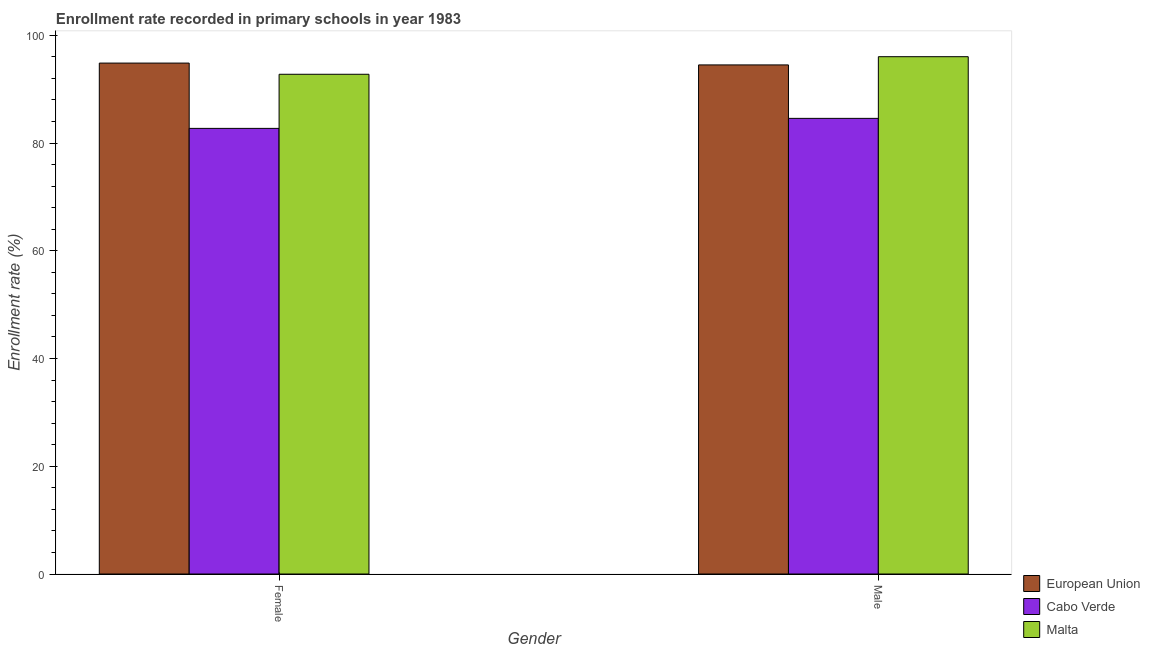How many different coloured bars are there?
Give a very brief answer. 3. How many groups of bars are there?
Your response must be concise. 2. How many bars are there on the 2nd tick from the left?
Give a very brief answer. 3. What is the enrollment rate of male students in Cabo Verde?
Provide a short and direct response. 84.59. Across all countries, what is the maximum enrollment rate of female students?
Give a very brief answer. 94.85. Across all countries, what is the minimum enrollment rate of male students?
Your response must be concise. 84.59. In which country was the enrollment rate of female students minimum?
Make the answer very short. Cabo Verde. What is the total enrollment rate of male students in the graph?
Your answer should be very brief. 275.13. What is the difference between the enrollment rate of female students in Cabo Verde and that in European Union?
Give a very brief answer. -12.12. What is the difference between the enrollment rate of female students in Cabo Verde and the enrollment rate of male students in European Union?
Provide a short and direct response. -11.78. What is the average enrollment rate of female students per country?
Offer a terse response. 90.12. What is the difference between the enrollment rate of female students and enrollment rate of male students in Cabo Verde?
Offer a very short reply. -1.86. In how many countries, is the enrollment rate of male students greater than 24 %?
Your response must be concise. 3. What is the ratio of the enrollment rate of male students in European Union to that in Cabo Verde?
Provide a succinct answer. 1.12. Is the enrollment rate of female students in Malta less than that in Cabo Verde?
Your answer should be compact. No. What does the 1st bar from the left in Female represents?
Provide a short and direct response. European Union. What does the 2nd bar from the right in Male represents?
Give a very brief answer. Cabo Verde. How many bars are there?
Your answer should be compact. 6. Are the values on the major ticks of Y-axis written in scientific E-notation?
Offer a terse response. No. Does the graph contain grids?
Your answer should be very brief. No. What is the title of the graph?
Provide a short and direct response. Enrollment rate recorded in primary schools in year 1983. What is the label or title of the X-axis?
Offer a terse response. Gender. What is the label or title of the Y-axis?
Your answer should be very brief. Enrollment rate (%). What is the Enrollment rate (%) of European Union in Female?
Provide a succinct answer. 94.85. What is the Enrollment rate (%) in Cabo Verde in Female?
Your answer should be very brief. 82.73. What is the Enrollment rate (%) in Malta in Female?
Offer a very short reply. 92.77. What is the Enrollment rate (%) in European Union in Male?
Give a very brief answer. 94.51. What is the Enrollment rate (%) in Cabo Verde in Male?
Your response must be concise. 84.59. What is the Enrollment rate (%) in Malta in Male?
Keep it short and to the point. 96.04. Across all Gender, what is the maximum Enrollment rate (%) of European Union?
Ensure brevity in your answer.  94.85. Across all Gender, what is the maximum Enrollment rate (%) in Cabo Verde?
Provide a short and direct response. 84.59. Across all Gender, what is the maximum Enrollment rate (%) in Malta?
Your response must be concise. 96.04. Across all Gender, what is the minimum Enrollment rate (%) in European Union?
Provide a short and direct response. 94.51. Across all Gender, what is the minimum Enrollment rate (%) of Cabo Verde?
Keep it short and to the point. 82.73. Across all Gender, what is the minimum Enrollment rate (%) of Malta?
Offer a terse response. 92.77. What is the total Enrollment rate (%) of European Union in the graph?
Keep it short and to the point. 189.36. What is the total Enrollment rate (%) of Cabo Verde in the graph?
Provide a succinct answer. 167.31. What is the total Enrollment rate (%) of Malta in the graph?
Make the answer very short. 188.81. What is the difference between the Enrollment rate (%) in European Union in Female and that in Male?
Provide a succinct answer. 0.34. What is the difference between the Enrollment rate (%) in Cabo Verde in Female and that in Male?
Offer a very short reply. -1.86. What is the difference between the Enrollment rate (%) in Malta in Female and that in Male?
Offer a terse response. -3.26. What is the difference between the Enrollment rate (%) in European Union in Female and the Enrollment rate (%) in Cabo Verde in Male?
Your response must be concise. 10.26. What is the difference between the Enrollment rate (%) of European Union in Female and the Enrollment rate (%) of Malta in Male?
Your response must be concise. -1.19. What is the difference between the Enrollment rate (%) in Cabo Verde in Female and the Enrollment rate (%) in Malta in Male?
Provide a short and direct response. -13.31. What is the average Enrollment rate (%) of European Union per Gender?
Make the answer very short. 94.68. What is the average Enrollment rate (%) in Cabo Verde per Gender?
Your answer should be very brief. 83.66. What is the average Enrollment rate (%) of Malta per Gender?
Your answer should be compact. 94.4. What is the difference between the Enrollment rate (%) in European Union and Enrollment rate (%) in Cabo Verde in Female?
Your answer should be compact. 12.12. What is the difference between the Enrollment rate (%) in European Union and Enrollment rate (%) in Malta in Female?
Give a very brief answer. 2.08. What is the difference between the Enrollment rate (%) of Cabo Verde and Enrollment rate (%) of Malta in Female?
Give a very brief answer. -10.04. What is the difference between the Enrollment rate (%) in European Union and Enrollment rate (%) in Cabo Verde in Male?
Offer a very short reply. 9.92. What is the difference between the Enrollment rate (%) of European Union and Enrollment rate (%) of Malta in Male?
Give a very brief answer. -1.53. What is the difference between the Enrollment rate (%) of Cabo Verde and Enrollment rate (%) of Malta in Male?
Your answer should be compact. -11.45. What is the difference between the highest and the second highest Enrollment rate (%) of European Union?
Provide a succinct answer. 0.34. What is the difference between the highest and the second highest Enrollment rate (%) in Cabo Verde?
Keep it short and to the point. 1.86. What is the difference between the highest and the second highest Enrollment rate (%) in Malta?
Offer a terse response. 3.26. What is the difference between the highest and the lowest Enrollment rate (%) in European Union?
Your answer should be very brief. 0.34. What is the difference between the highest and the lowest Enrollment rate (%) of Cabo Verde?
Offer a terse response. 1.86. What is the difference between the highest and the lowest Enrollment rate (%) in Malta?
Provide a succinct answer. 3.26. 